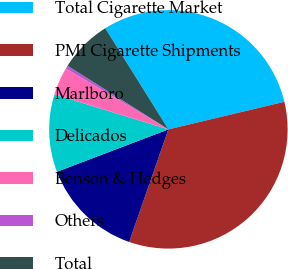<chart> <loc_0><loc_0><loc_500><loc_500><pie_chart><fcel>Total Cigarette Market<fcel>PMI Cigarette Shipments<fcel>Marlboro<fcel>Delicados<fcel>Benson & Hedges<fcel>Others<fcel>Total<nl><fcel>30.17%<fcel>34.05%<fcel>13.88%<fcel>10.52%<fcel>3.79%<fcel>0.43%<fcel>7.16%<nl></chart> 